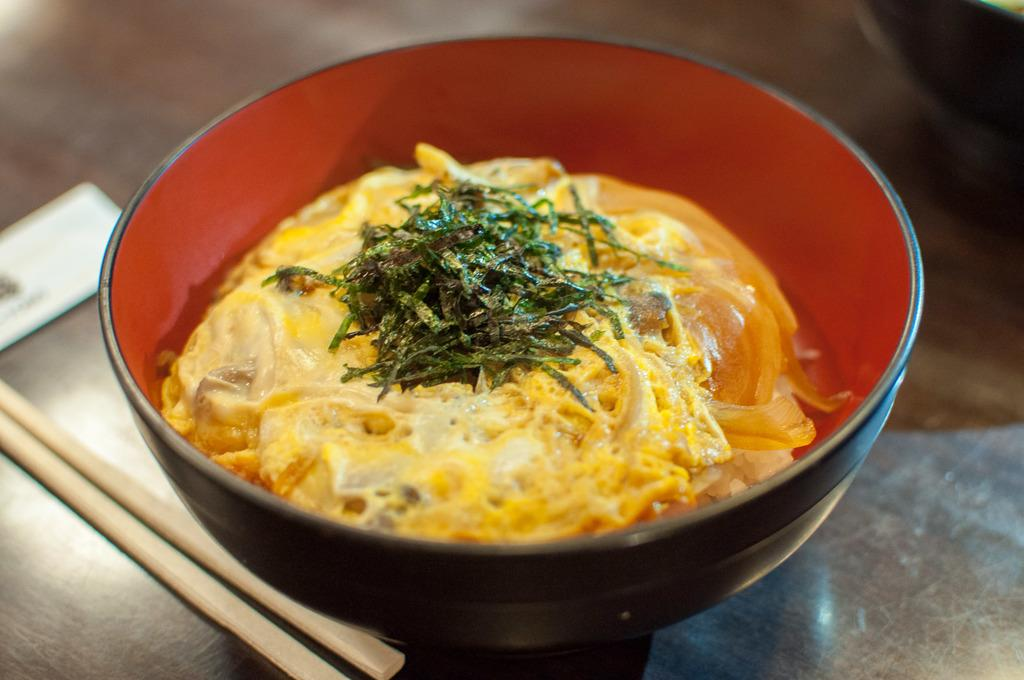What is in the bowl that is visible in the image? There is food in a bowl in the image. What utensil is present on the table in the image? There are chopsticks on the table in the image. What type of linen is being used as a tablecloth in the image? There is no linen or tablecloth visible in the image. 